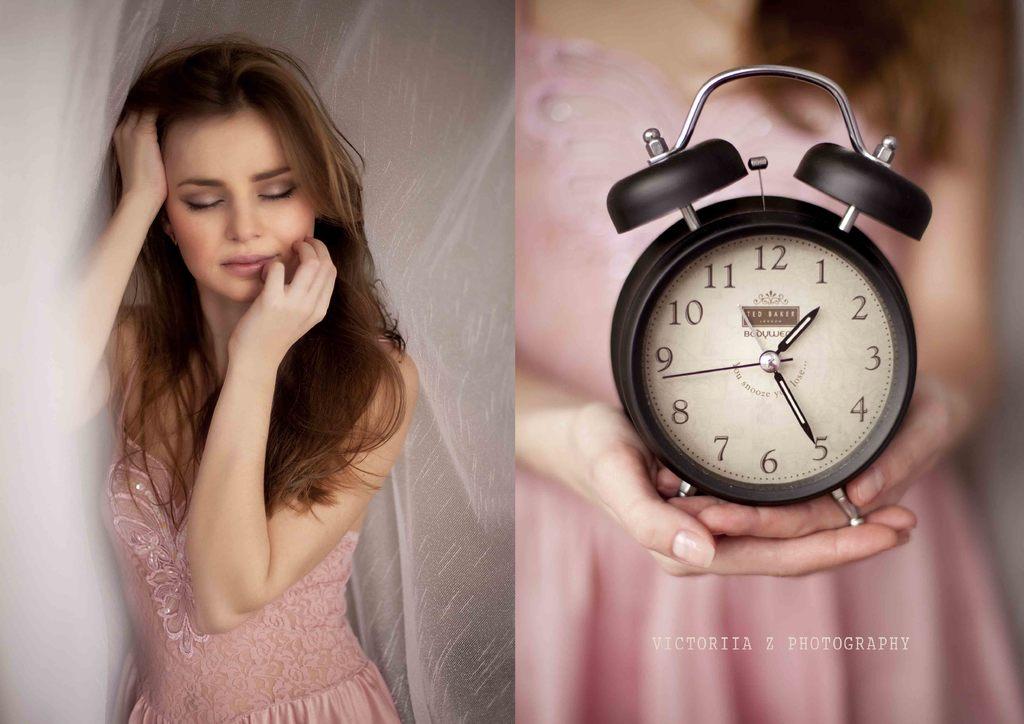What time is shown on the clock?
Offer a terse response. 1:25. What number is the minute hand pointing to?
Offer a very short reply. 5. 